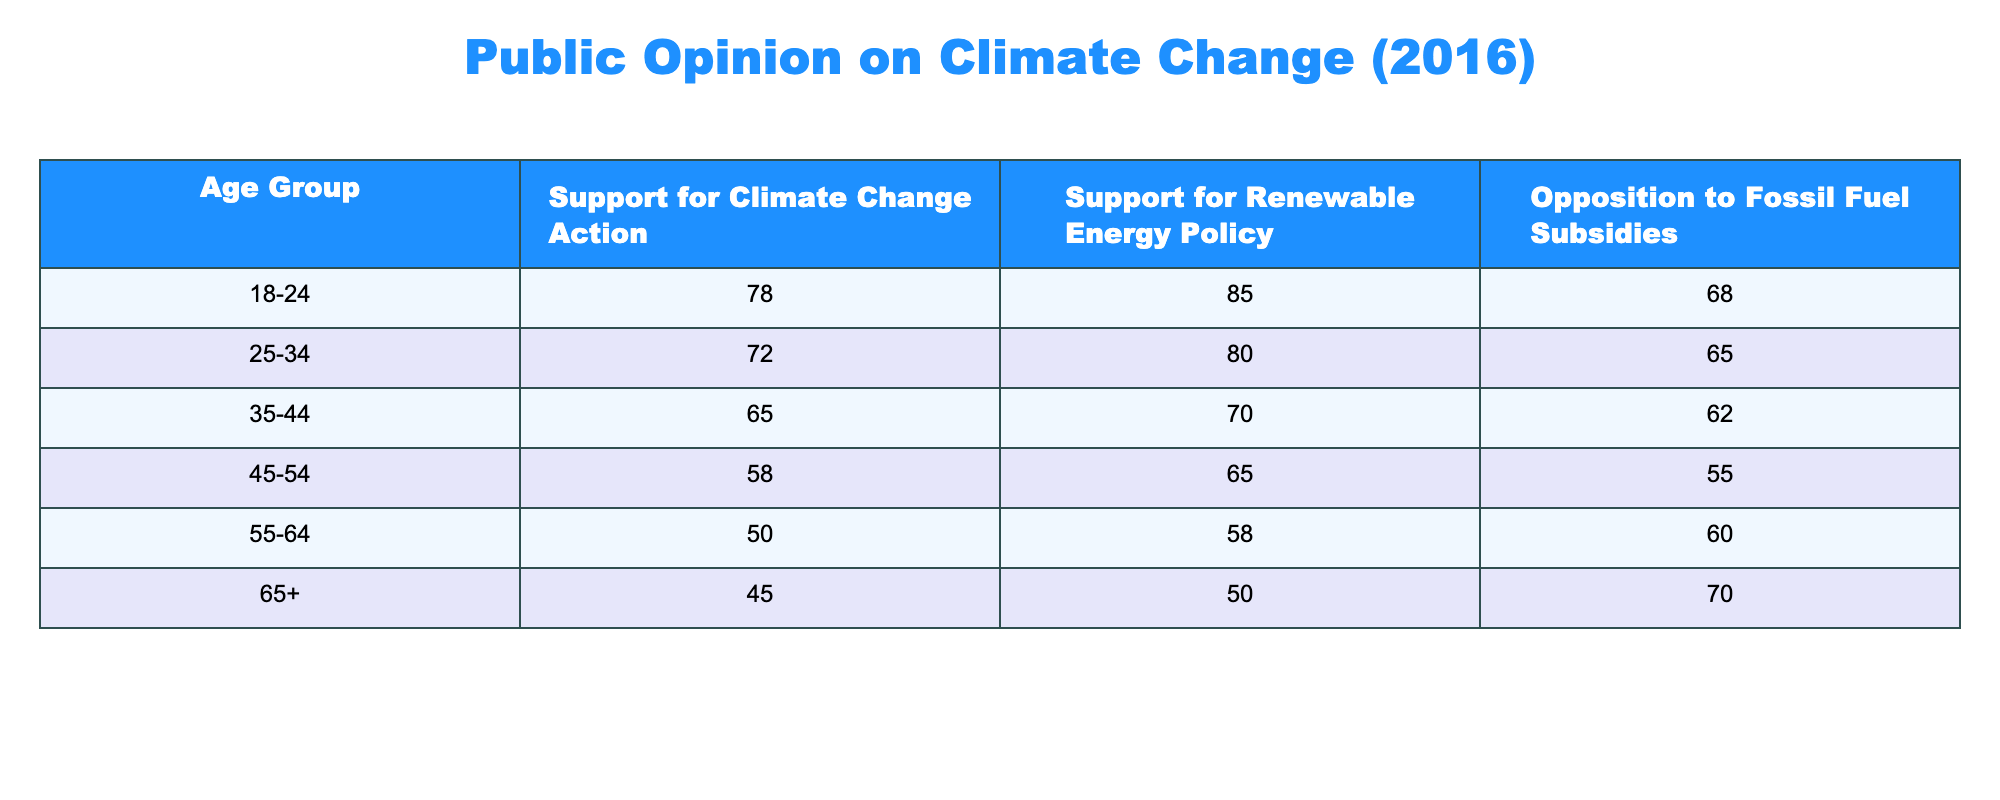What percentage of 18 to 24-year-olds support renewable energy policy? The table shows that 85% of people in the 18-24 age group support renewable energy policy.
Answer: 85% Which age group has the highest opposition to fossil fuel subsidies? The 65+ age group has the highest opposition to fossil fuel subsidies at 70%.
Answer: 70% What is the average support for climate change action across all age groups? To find the average, we add the support values: 78 + 72 + 65 + 58 + 50 + 45 = 368. There are 6 age groups, so the average is 368 / 6 = 61.33.
Answer: 61.33 Is it true that the support for climate change action decreases with age? By comparing the support percentages from different age groups, it's clear that support does decrease as age increases (from 78% in 18-24 to 45% in 65+). Therefore, the statement is true.
Answer: Yes What is the difference in support for climate change action between the 18-24 and 55-64 age groups? The support in the 18-24 age group is 78%, and in the 55-64 group it is 50%. The difference is calculated as 78 - 50 = 28.
Answer: 28 What percentage of those aged 45-54 support renewable energy policy? The table indicates that 65% of the 45-54 age group support renewable energy policy.
Answer: 65% Which age group has the lowest support for climate change action and what is that percentage? The lowest support for climate change action is in the 65+ age group at 45%.
Answer: 45% How does the support for renewable energy policy compare between the 35-44 and 25-34 age groups? The support in the 35-44 age group is 70% and in the 25-34 age group it is 80%. The 25-34 age group shows higher support by 10%.
Answer: 10% higher in 25-34 age group 